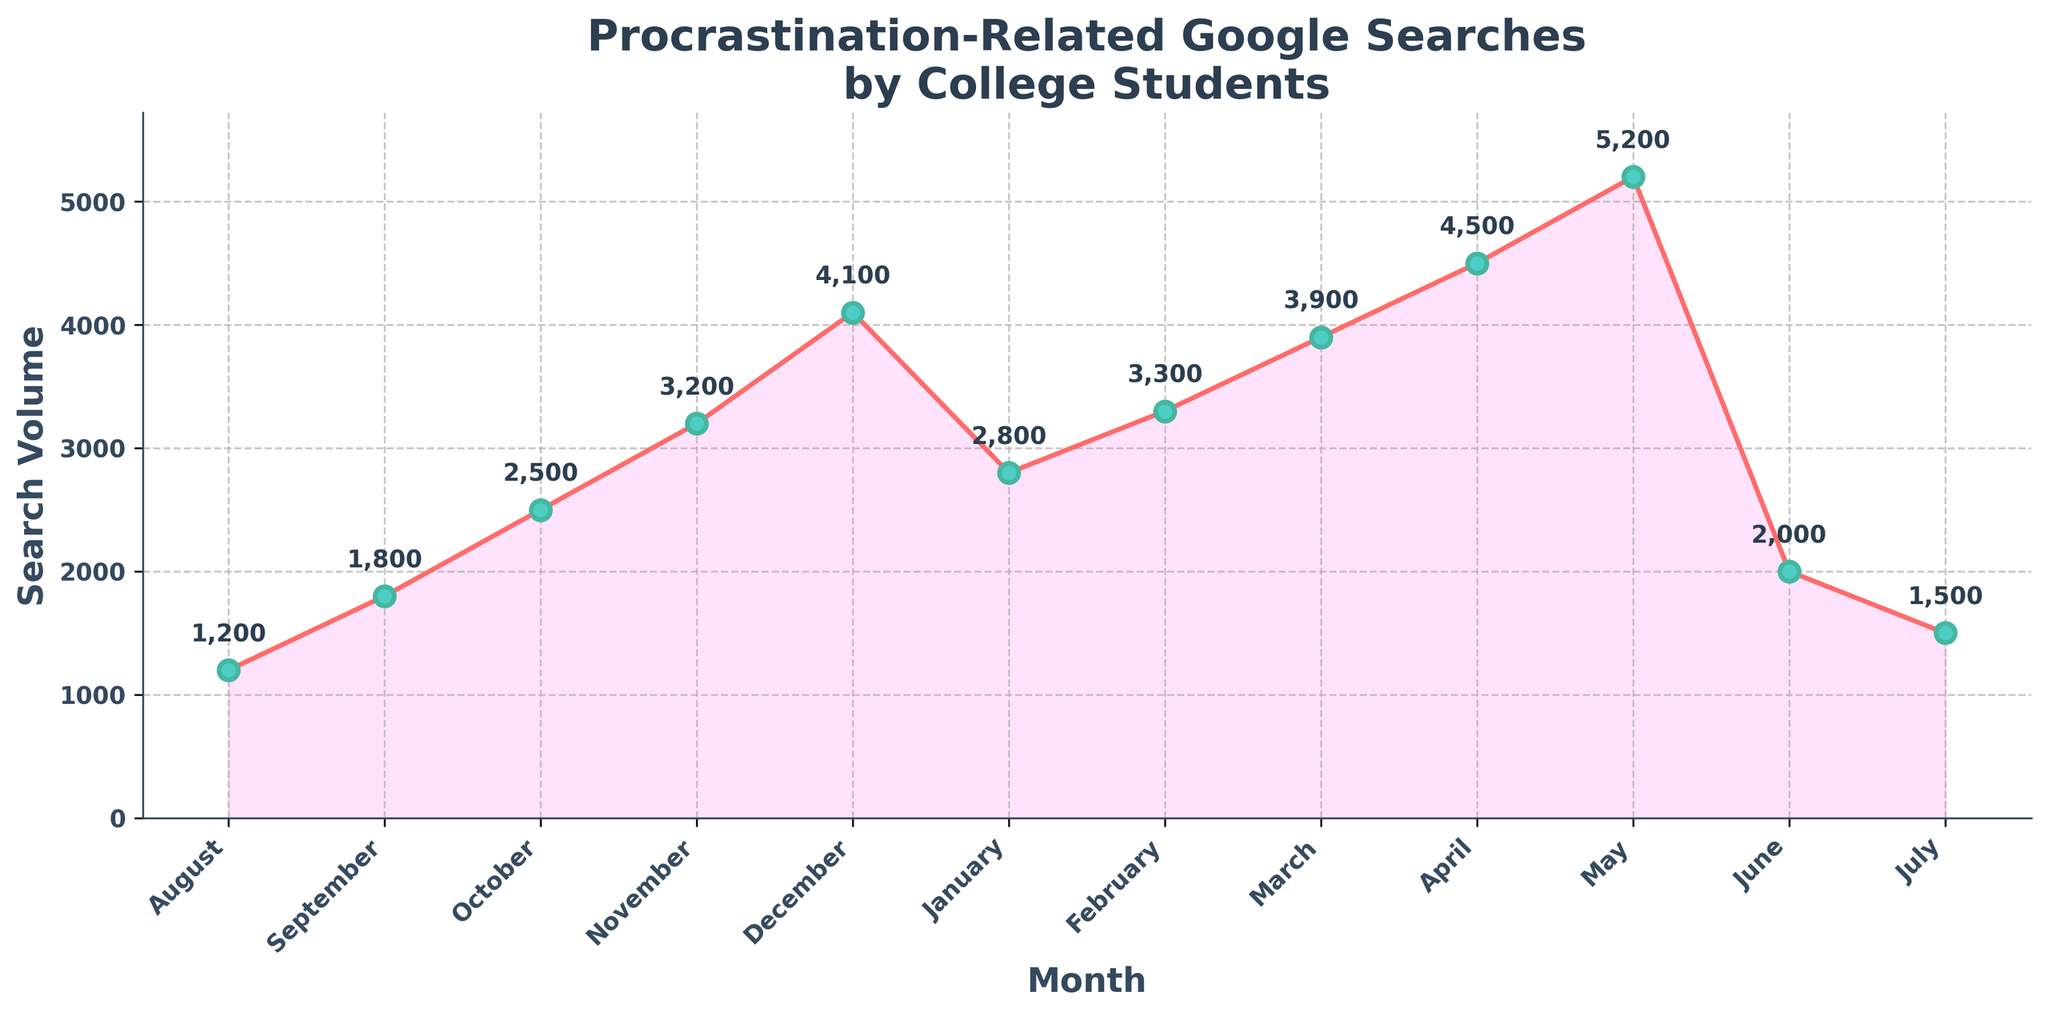What's the peak month for procrastination-related Google searches? The peak month is the one with the highest search volume shown on the chart. The highest point on the line graph is in May with a search volume of 5200.
Answer: May How does the search volume in November compare to that in March? By comparing the search volumes for November (3200) and March (3900), it's clear that March has a higher search volume.
Answer: March has a higher search volume Which month shows the largest percentage increase in search volume compared to the previous month? Calculate the percentage increase for each month compared to the previous month. For example, from August (1200) to September (1800), the increase is ((1800-1200)/1200)*100 ≈ 50%. Continue this for each month to find that April shows the largest increase ((4500-3900)/3900)*100 ≈ 15.4%.
Answer: April What is the search volume difference between December and January? Subtract January's search volume (2800) from December's (4100): 4100 - 2800 = 1300.
Answer: 1300 In which month does the search volume drop the most drastically compared to the previous month? Calculate the drop in search volume for each month. The largest drop is from May (5200) to June (2000), a drop of 5200 - 2000 = 3200.
Answer: June If the average search volume for the year is calculated, would it be higher than the search volume in February? Find the average search volume by summing all values and dividing by 12. Total search volume over the year is 39500, the average is 39500/12 ≈ 3291.67. Compare it to February's search volume (3300).
Answer: No What is the combined search volume for the first and second half of the year respectively? Sum the search volumes for January to June (January: 2800, February: 3300, March: 3900, April: 4500, May: 5200, June: 2000). Sum for the first half is 21700. Sum for July to December (July: 1500, August: 1200, September: 1800, October: 2500, November: 3200, December: 4100) is 17800.
Answer: 21700 for January to June, 17800 for July to December How does the range of search volumes compare between the first half and the second half of the year? The range is the difference between the maximum and minimum values in each half. For January to June (max 5200, min 2000), range is 5200 - 2000 = 3200. For July to December (max 4100, min 1200), range is 4100 - 1200 = 2900.
Answer: 3200 for the first half, 2900 for the second half 